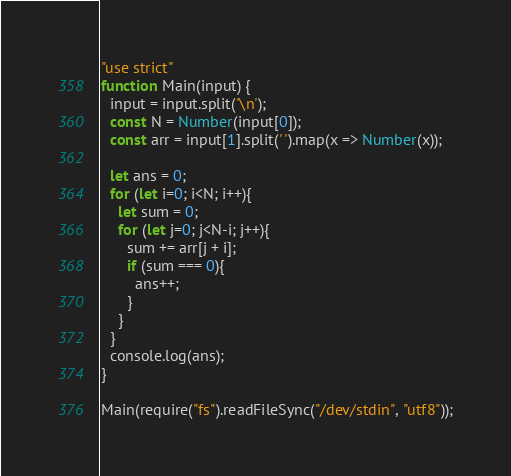<code> <loc_0><loc_0><loc_500><loc_500><_JavaScript_>"use strict"
function Main(input) {
  input = input.split('\n');
  const N = Number(input[0]);
  const arr = input[1].split(' ').map(x => Number(x));
 
  let ans = 0;
  for (let i=0; i<N; i++){
    let sum = 0;
    for (let j=0; j<N-i; j++){
      sum += arr[j + i];
      if (sum === 0){
        ans++;
      }
    }
  }
  console.log(ans);
}
 
Main(require("fs").readFileSync("/dev/stdin", "utf8"));</code> 